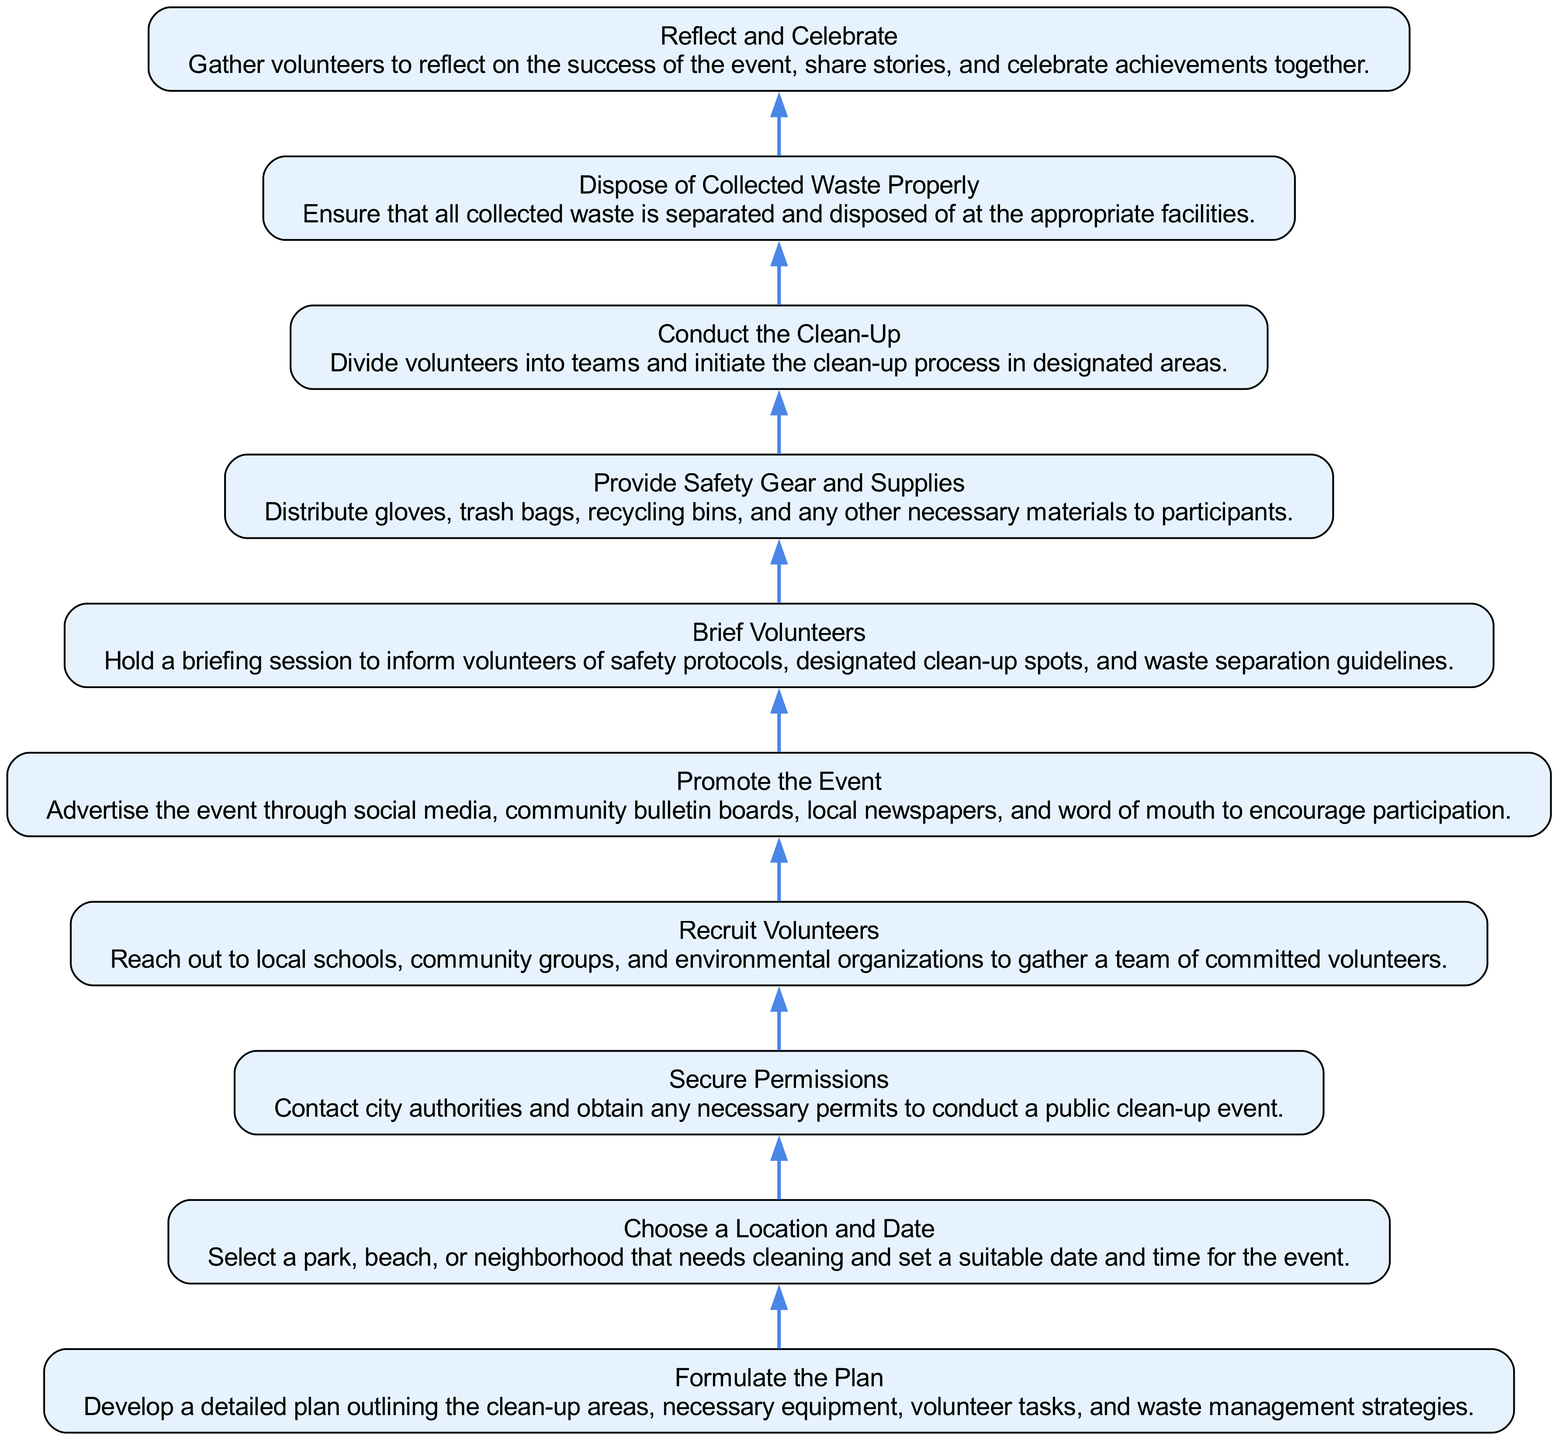What is the first step in organizing a community clean-up event? The first step, starting from the bottom of the flow chart, is "Reflect and Celebrate," as it is the last element in the flow order.
Answer: Reflect and Celebrate How many nodes are present in the diagram? The diagram contains a total of ten nodes, as there are ten distinct elements listed from bottom to top.
Answer: 10 What is the last action taken before the clean-up starts? The action just before "Conduct the Clean-Up" is "Brief Volunteers," which involves informing them about safety and procedures.
Answer: Brief Volunteers What action is taken immediately after recruiting volunteers? After "Recruit Volunteers," the next action in the flow is "Secure Permissions," where necessary permits are obtained for the event.
Answer: Secure Permissions Which two actions focus on volunteer management and preparation? The two actions that focus on managing and preparing volunteers are "Brief Volunteers" and "Provide Safety Gear and Supplies." Both are crucial before the activity can commence.
Answer: Brief Volunteers and Provide Safety Gear and Supplies How are volunteers informed about safety protocols? Volunteers are informed about safety protocols during the "Brief Volunteers" step, where they receive guidance before the clean-up begins.
Answer: Brief Volunteers What signifies the completion of the clean-up event process? The completion of the clean-up event process is signified by "Dispose of Collected Waste Properly," ensuring all waste is handled appropriately.
Answer: Dispose of Collected Waste Properly Which step comes right after promoting the event? Right after "Promote the Event," the subsequent step is "Recruit Volunteers," where effort is put into gathering a team for the clean-up.
Answer: Recruit Volunteers What is the main purpose of the "Formulate the Plan" step? The main purpose of the "Formulate the Plan" step is to develop a detailed outline for the clean-up strategy, including areas to be cleaned and team assignments.
Answer: Develop a detailed plan 